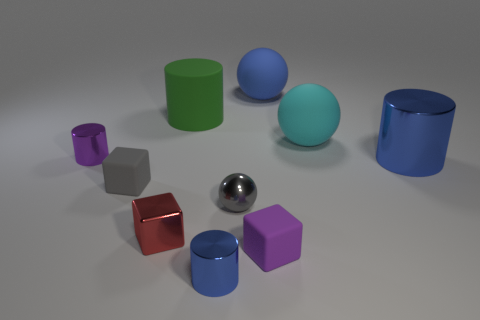Subtract all purple matte cubes. How many cubes are left? 2 Subtract all purple cylinders. How many cylinders are left? 3 Subtract all yellow cylinders. Subtract all gray blocks. How many cylinders are left? 4 Subtract all cubes. How many objects are left? 7 Add 1 big blue matte objects. How many big blue matte objects are left? 2 Add 9 tiny cyan things. How many tiny cyan things exist? 9 Subtract 1 red cubes. How many objects are left? 9 Subtract all tiny gray matte objects. Subtract all small metal cubes. How many objects are left? 8 